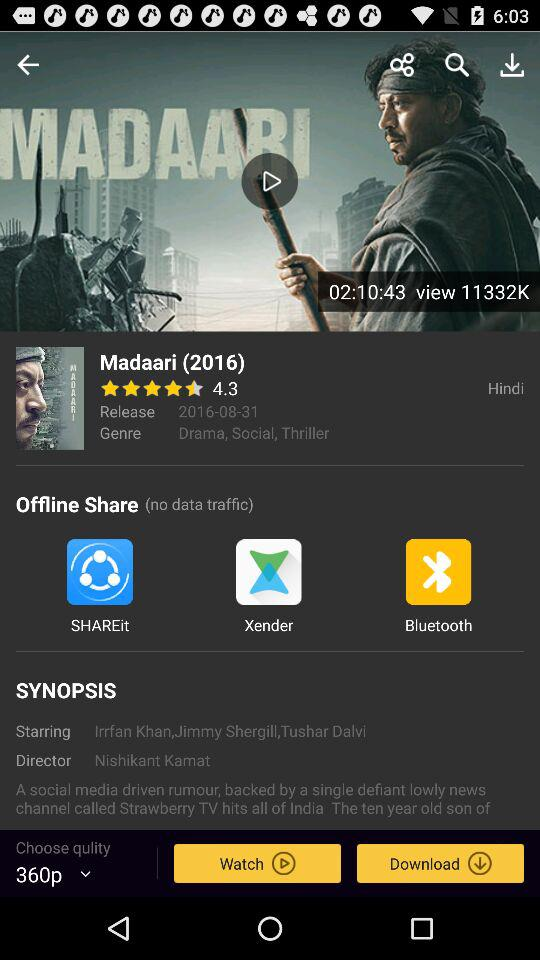What's the genre of the movie? The genre of the movie is drama, social and thriller. 